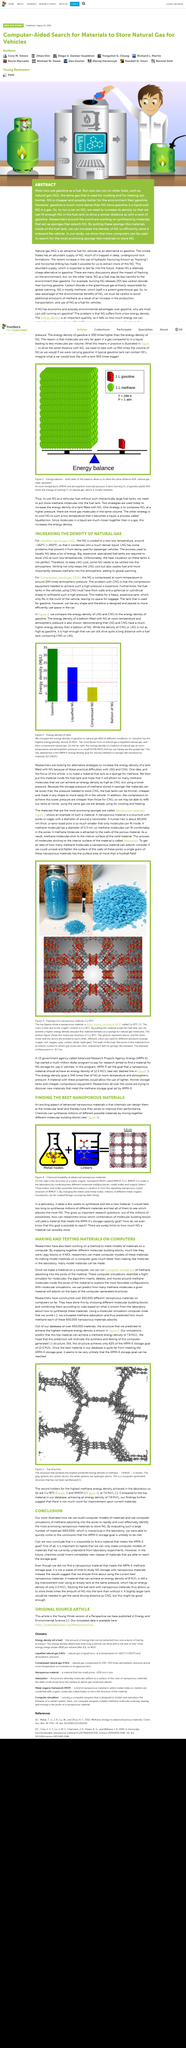Outline some significant characteristics in this image. Yes, computer simulation resembles a flight simulator for molecules. Natural gas is kept cool through the use of large, specialized fuel tanks designed specifically for this purpose. Natural gas is densified by cooling it to a very low temperature of approximately -162 degrees Celsius. Chemists have the ability to design and create nanoporous materials at the molecular level, which have a wide range of applications in various fields. The process of liquefying natural gas is plagued by several issues that are detrimental to the environment and the economy. Firstly, it requires a significant amount of energy, which is both costly and wasteful. Secondly, fuel is lost during the process, resulting in unnecessary expenditure and environmental degradation. Thirdly, methane, a harmful greenhouse gas, is released into the atmosphere, exacerbating climate change. 